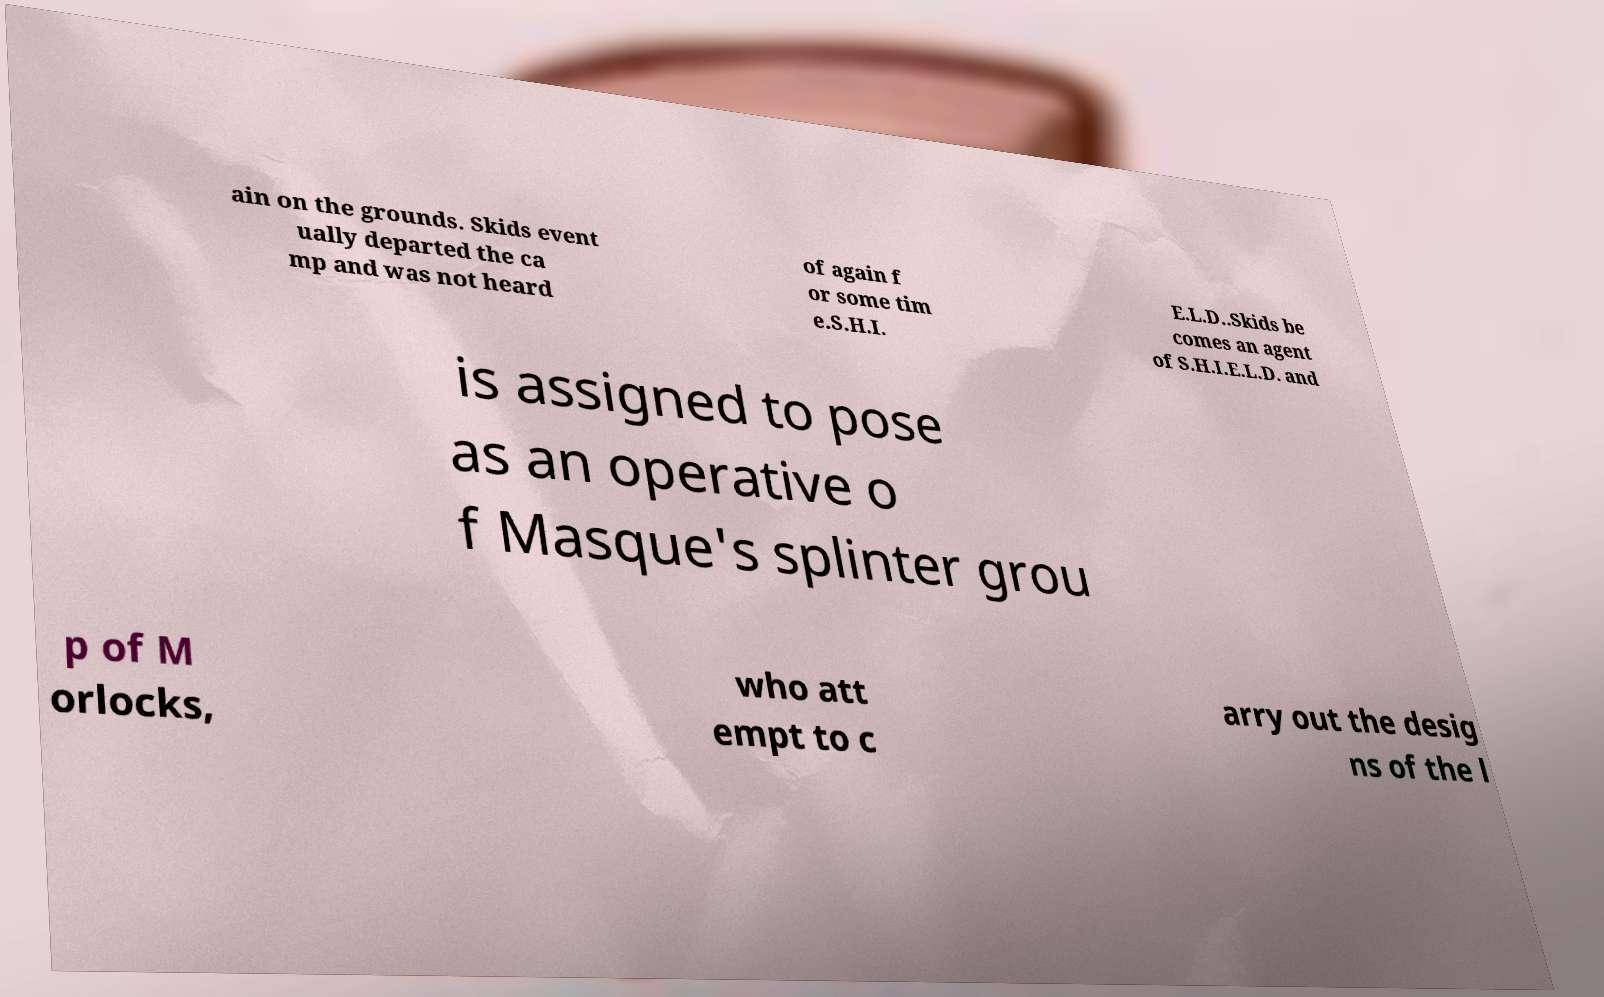For documentation purposes, I need the text within this image transcribed. Could you provide that? ain on the grounds. Skids event ually departed the ca mp and was not heard of again f or some tim e.S.H.I. E.L.D..Skids be comes an agent of S.H.I.E.L.D. and is assigned to pose as an operative o f Masque's splinter grou p of M orlocks, who att empt to c arry out the desig ns of the l 